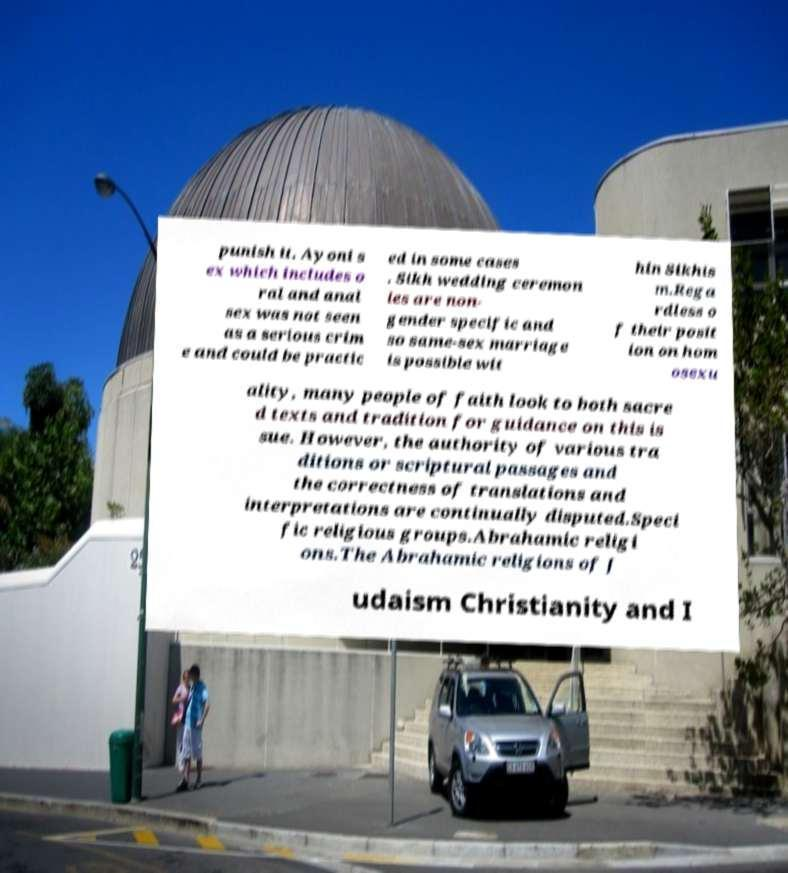What messages or text are displayed in this image? I need them in a readable, typed format. punish it. Ayoni s ex which includes o ral and anal sex was not seen as a serious crim e and could be practic ed in some cases . Sikh wedding ceremon ies are non- gender specific and so same-sex marriage is possible wit hin Sikhis m.Rega rdless o f their posit ion on hom osexu ality, many people of faith look to both sacre d texts and tradition for guidance on this is sue. However, the authority of various tra ditions or scriptural passages and the correctness of translations and interpretations are continually disputed.Speci fic religious groups.Abrahamic religi ons.The Abrahamic religions of J udaism Christianity and I 